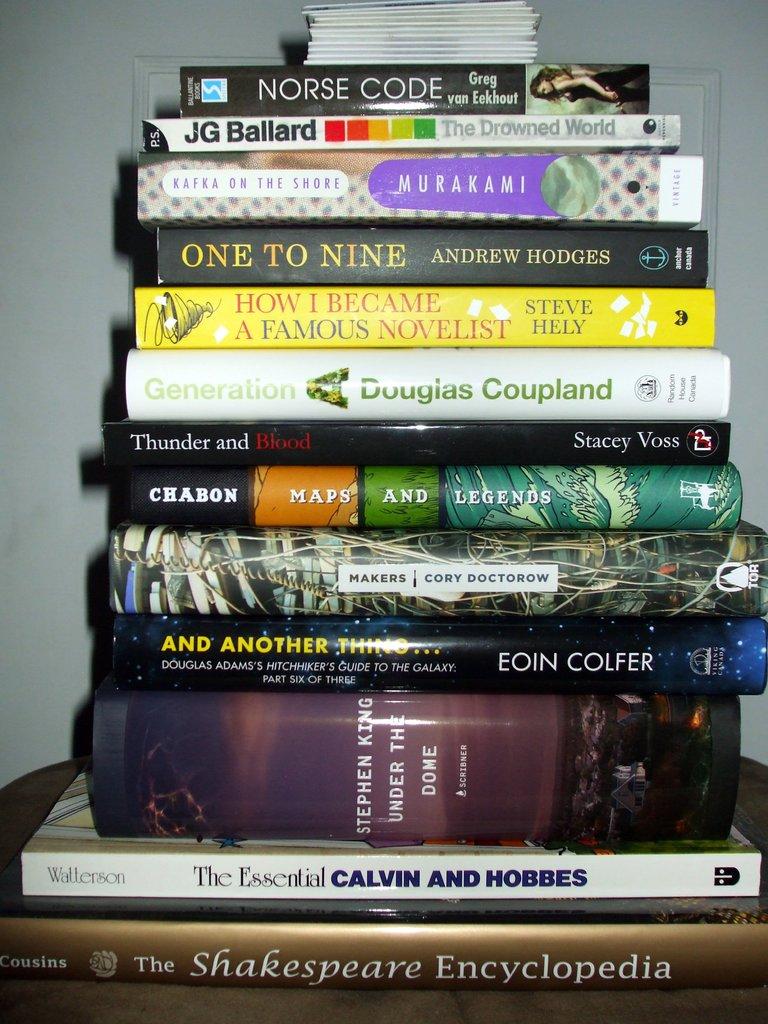Who wrote and illustrated the essential calvin and hobbes?
Offer a very short reply. Watterson. 